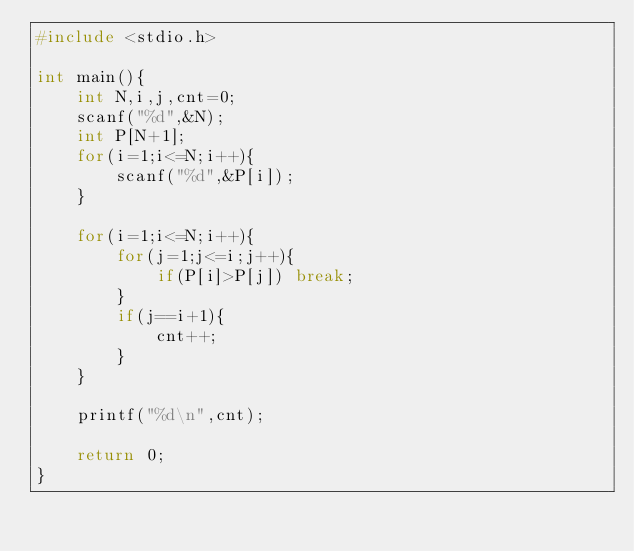<code> <loc_0><loc_0><loc_500><loc_500><_C_>#include <stdio.h>

int main(){
    int N,i,j,cnt=0;
    scanf("%d",&N);
    int P[N+1];
    for(i=1;i<=N;i++){
        scanf("%d",&P[i]);
    }

    for(i=1;i<=N;i++){
        for(j=1;j<=i;j++){
            if(P[i]>P[j]) break;
        }
        if(j==i+1){
            cnt++;
        }
    }

    printf("%d\n",cnt);

    return 0;
}</code> 